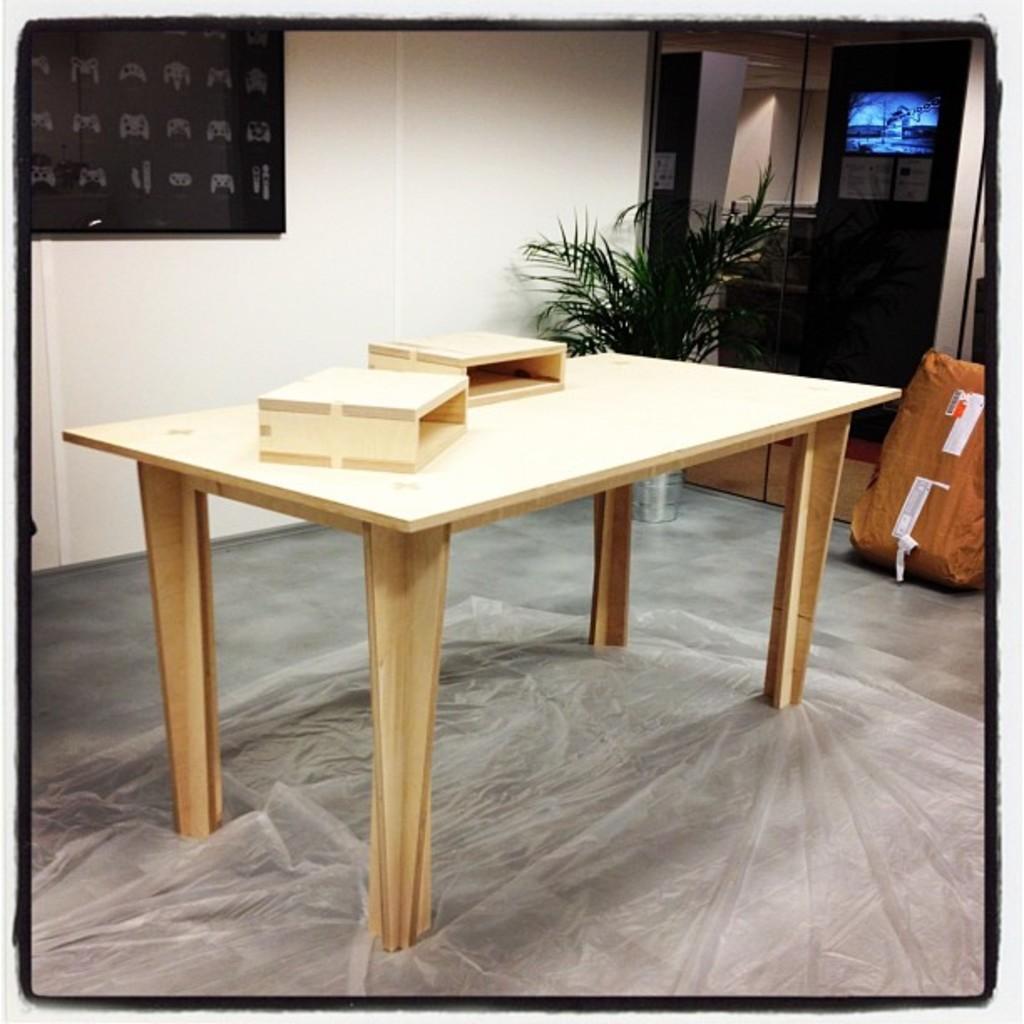Please provide a concise description of this image. As we can see in the image there is a white color wall, table, cover, plant and a door. 